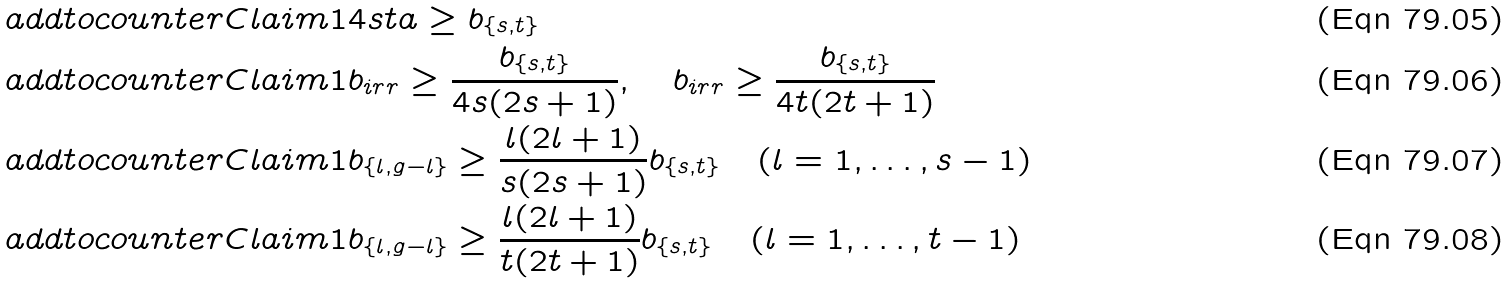Convert formula to latex. <formula><loc_0><loc_0><loc_500><loc_500>\ a d d t o c o u n t e r { C l a i m } { 1 } & 4 s t a \geq b _ { \{ s , t \} } \\ \ a d d t o c o u n t e r { C l a i m } { 1 } & b _ { i r r } \geq \frac { b _ { \{ s , t \} } } { 4 s ( 2 s + 1 ) } , \quad b _ { i r r } \geq \frac { b _ { \{ s , t \} } } { 4 t ( 2 t + 1 ) } \\ \ a d d t o c o u n t e r { C l a i m } { 1 } & b _ { \{ l , g - l \} } \geq \frac { l ( 2 l + 1 ) } { s ( 2 s + 1 ) } b _ { \{ s , t \} } \quad ( l = 1 , \dots , s - 1 ) \\ \ a d d t o c o u n t e r { C l a i m } { 1 } & b _ { \{ l , g - l \} } \geq \frac { l ( 2 l + 1 ) } { t ( 2 t + 1 ) } b _ { \{ s , t \} } \quad ( l = 1 , \dots , t - 1 )</formula> 